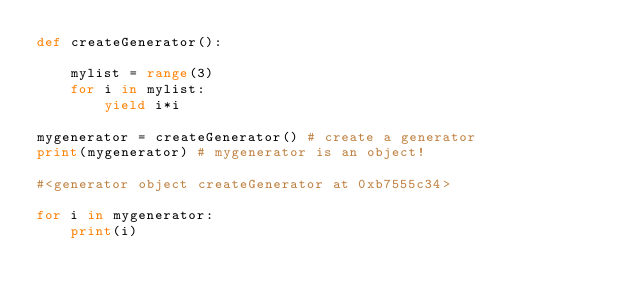Convert code to text. <code><loc_0><loc_0><loc_500><loc_500><_Python_>def createGenerator():
    
    mylist = range(3)
    for i in mylist:
        yield i*i
        
mygenerator = createGenerator() # create a generator
print(mygenerator) # mygenerator is an object!

#<generator object createGenerator at 0xb7555c34>

for i in mygenerator:
    print(i)

</code> 